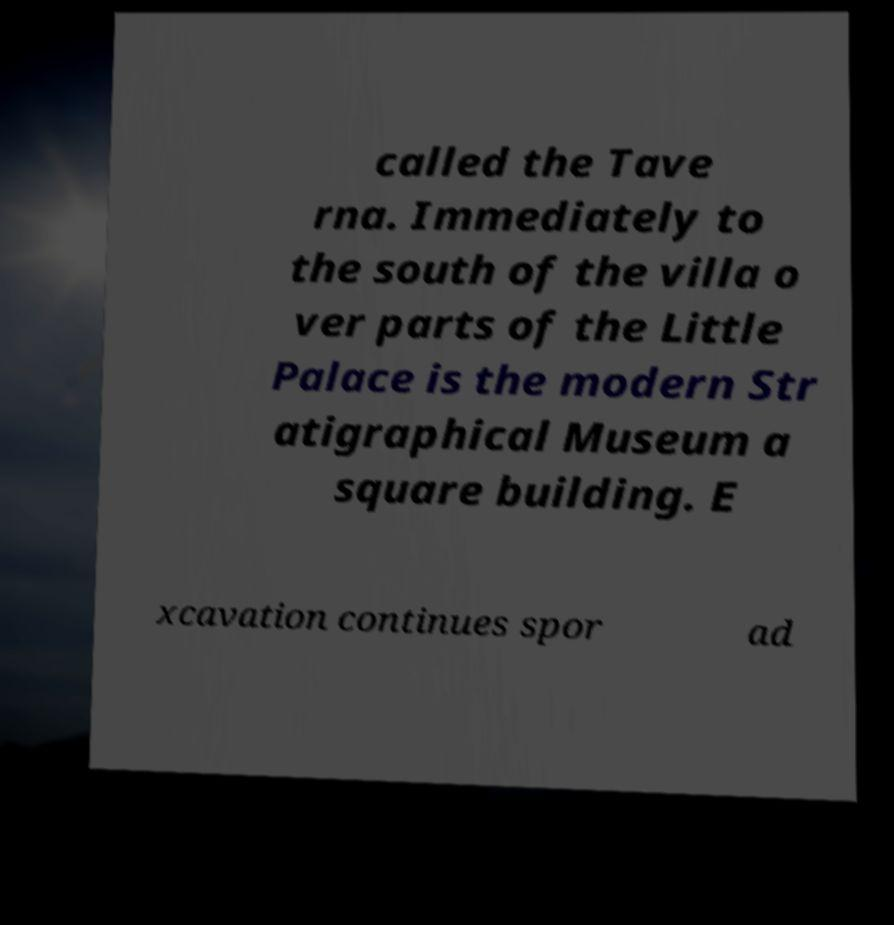Can you accurately transcribe the text from the provided image for me? called the Tave rna. Immediately to the south of the villa o ver parts of the Little Palace is the modern Str atigraphical Museum a square building. E xcavation continues spor ad 